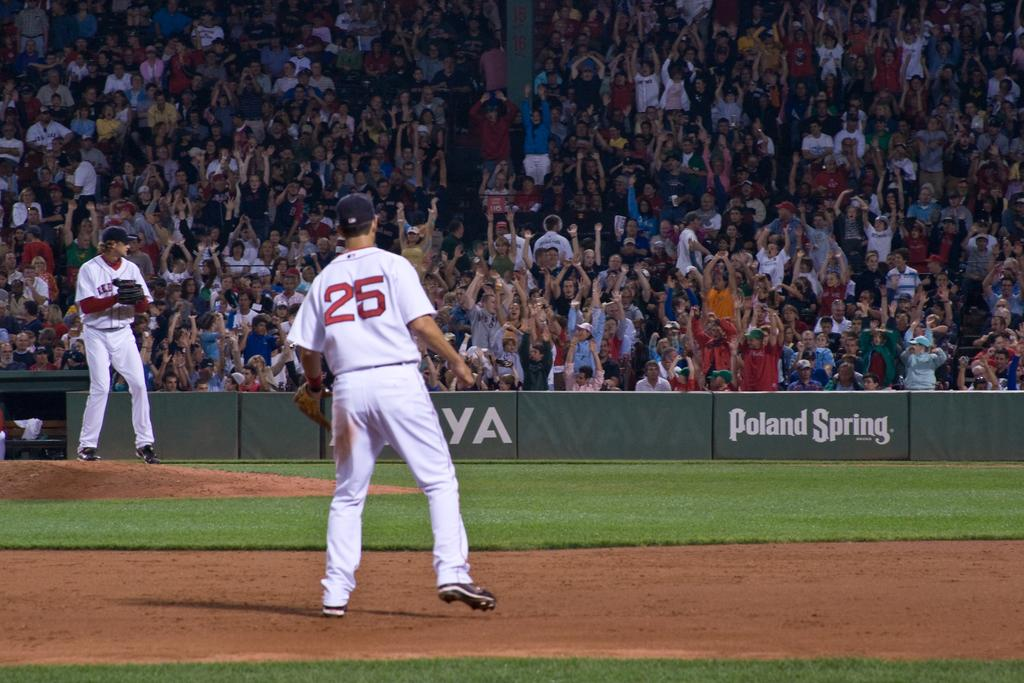<image>
Offer a succinct explanation of the picture presented. number 25 baseball player on a field sponsored by poland spring 